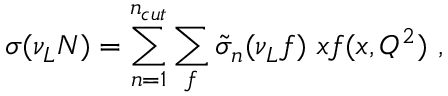<formula> <loc_0><loc_0><loc_500><loc_500>\sigma ( \nu _ { L } N ) = \sum _ { n = 1 } ^ { n _ { c u t } } \sum _ { f } \tilde { \sigma } _ { n } ( \nu _ { L } f ) \ x f ( x , Q ^ { 2 } ) \ ,</formula> 